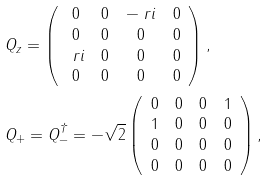Convert formula to latex. <formula><loc_0><loc_0><loc_500><loc_500>& Q _ { z } = \left ( \begin{array} { c c c c } 0 & 0 & - \ r i & 0 \\ 0 & 0 & 0 & 0 \\ \ r i & 0 & 0 & 0 \\ 0 & 0 & 0 & 0 \end{array} \right ) , \\ & Q _ { + } = Q _ { - } ^ { \dagger } = - \sqrt { 2 } \left ( \begin{array} { c c c c } 0 & 0 & 0 & 1 \\ 1 & 0 & 0 & 0 \\ 0 & 0 & 0 & 0 \\ 0 & 0 & 0 & 0 \end{array} \right ) ,</formula> 